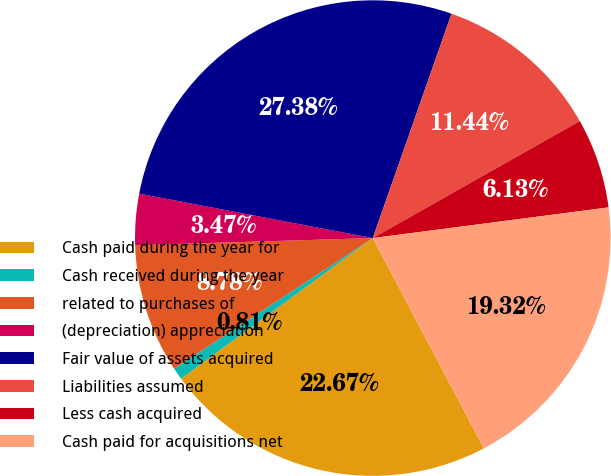Convert chart to OTSL. <chart><loc_0><loc_0><loc_500><loc_500><pie_chart><fcel>Cash paid during the year for<fcel>Cash received during the year<fcel>related to purchases of<fcel>(depreciation) appreciation<fcel>Fair value of assets acquired<fcel>Liabilities assumed<fcel>Less cash acquired<fcel>Cash paid for acquisitions net<nl><fcel>22.67%<fcel>0.81%<fcel>8.78%<fcel>3.47%<fcel>27.38%<fcel>11.44%<fcel>6.13%<fcel>19.32%<nl></chart> 